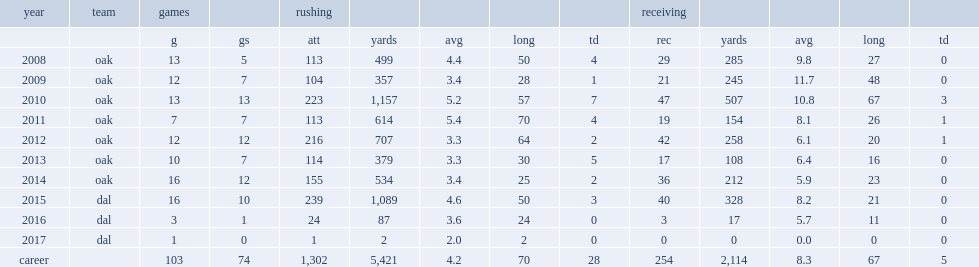How many rushing yards did darren mcfadden get in 2008? 499.0. 